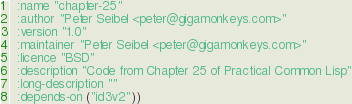Convert code to text. <code><loc_0><loc_0><loc_500><loc_500><_Lisp_>  :name "chapter-25"
  :author "Peter Seibel <peter@gigamonkeys.com>"
  :version "1.0"
  :maintainer "Peter Seibel <peter@gigamonkeys.com>"
  :licence "BSD"
  :description "Code from Chapter 25 of Practical Common Lisp"
  :long-description ""
  :depends-on ("id3v2"))
</code> 